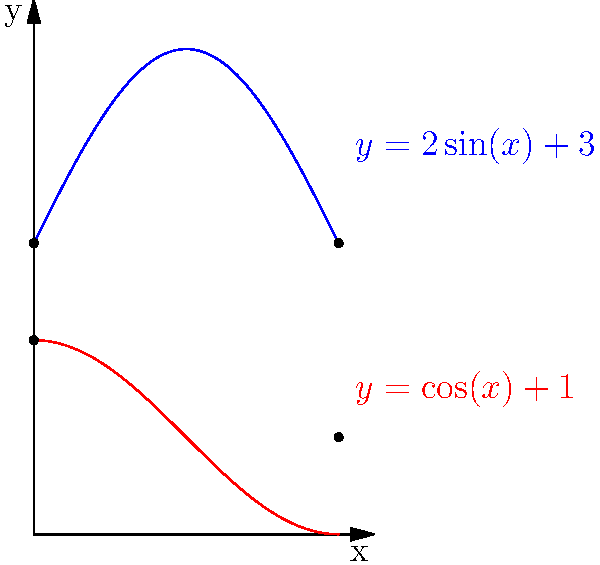As a field assistant studying forest dynamics, you've encountered an irregularly shaped forest clearing. The clearing's boundary can be modeled by two functions: $y = 2\sin(x) + 3$ (upper boundary) and $y = \cos(x) + 1$ (lower boundary) from $x = 0$ to $x = \pi$. Calculate the area of this clearing in square units. To find the area of the irregularly shaped forest clearing, we need to use integration to calculate the area between the two curves. Here's the step-by-step process:

1) The area between two curves is given by the formula:
   $$A = \int_{a}^{b} [f(x) - g(x)] dx$$
   where $f(x)$ is the upper function and $g(x)$ is the lower function.

2) In this case:
   $f(x) = 2\sin(x) + 3$
   $g(x) = \cos(x) + 1$
   $a = 0$ and $b = \pi$

3) Substituting into the formula:
   $$A = \int_{0}^{\pi} [(2\sin(x) + 3) - (\cos(x) + 1)] dx$$

4) Simplify the integrand:
   $$A = \int_{0}^{\pi} [2\sin(x) - \cos(x) + 2] dx$$

5) Integrate each term:
   $$A = [-2\cos(x) - \sin(x) + 2x]_{0}^{\pi}$$

6) Evaluate the integral:
   $$A = [-2\cos(\pi) - \sin(\pi) + 2\pi] - [-2\cos(0) - \sin(0) + 2(0)]$$
   $$A = [2 - 0 + 2\pi] - [-2 - 0 + 0]$$
   $$A = (2 + 2\pi) - (-2)$$
   $$A = 2\pi + 4$$

Therefore, the area of the forest clearing is $2\pi + 4$ square units.
Answer: $2\pi + 4$ square units 